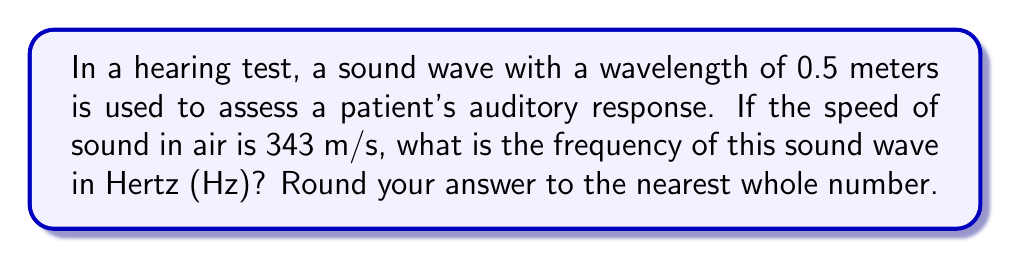What is the answer to this math problem? To solve this problem, we'll use the fundamental relationship between wavelength, frequency, and speed of sound:

$$v = f \lambda$$

Where:
$v$ = speed of sound in air (343 m/s)
$f$ = frequency of the sound wave (Hz)
$\lambda$ = wavelength of the sound wave (0.5 m)

We need to solve for $f$. Rearranging the equation:

$$f = \frac{v}{\lambda}$$

Now, let's substitute the known values:

$$f = \frac{343 \text{ m/s}}{0.5 \text{ m}}$$

Calculating:

$$f = 686 \text{ Hz}$$

Since we're asked to round to the nearest whole number, our final answer is 686 Hz.

This frequency falls within the audible range for humans (typically 20 Hz to 20,000 Hz), making it suitable for a hearing test. As an ENT specialist, you would use various frequencies to assess a patient's hearing across the audible spectrum.
Answer: 686 Hz 